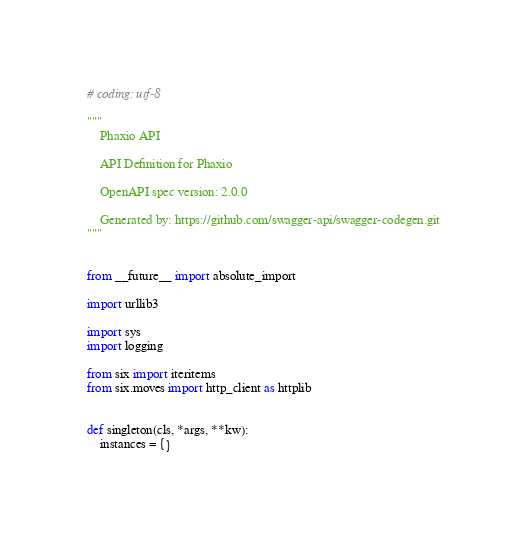<code> <loc_0><loc_0><loc_500><loc_500><_Python_># coding: utf-8

"""
    Phaxio API

    API Definition for Phaxio

    OpenAPI spec version: 2.0.0
    
    Generated by: https://github.com/swagger-api/swagger-codegen.git
"""


from __future__ import absolute_import

import urllib3

import sys
import logging

from six import iteritems
from six.moves import http_client as httplib


def singleton(cls, *args, **kw):
    instances = {}
</code> 